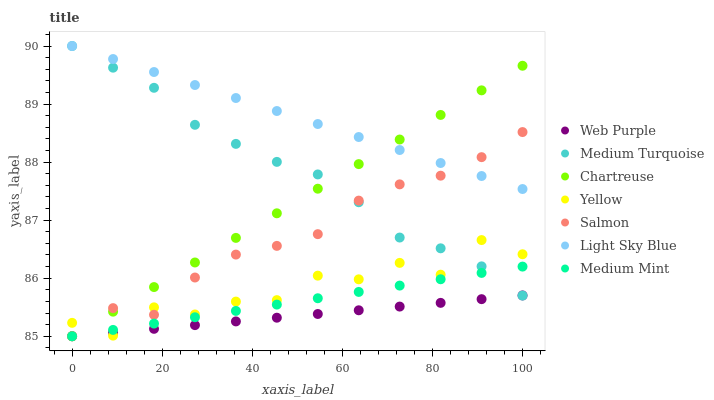Does Web Purple have the minimum area under the curve?
Answer yes or no. Yes. Does Light Sky Blue have the maximum area under the curve?
Answer yes or no. Yes. Does Salmon have the minimum area under the curve?
Answer yes or no. No. Does Salmon have the maximum area under the curve?
Answer yes or no. No. Is Light Sky Blue the smoothest?
Answer yes or no. Yes. Is Yellow the roughest?
Answer yes or no. Yes. Is Salmon the smoothest?
Answer yes or no. No. Is Salmon the roughest?
Answer yes or no. No. Does Medium Mint have the lowest value?
Answer yes or no. Yes. Does Yellow have the lowest value?
Answer yes or no. No. Does Medium Turquoise have the highest value?
Answer yes or no. Yes. Does Salmon have the highest value?
Answer yes or no. No. Is Yellow less than Light Sky Blue?
Answer yes or no. Yes. Is Light Sky Blue greater than Web Purple?
Answer yes or no. Yes. Does Yellow intersect Medium Turquoise?
Answer yes or no. Yes. Is Yellow less than Medium Turquoise?
Answer yes or no. No. Is Yellow greater than Medium Turquoise?
Answer yes or no. No. Does Yellow intersect Light Sky Blue?
Answer yes or no. No. 